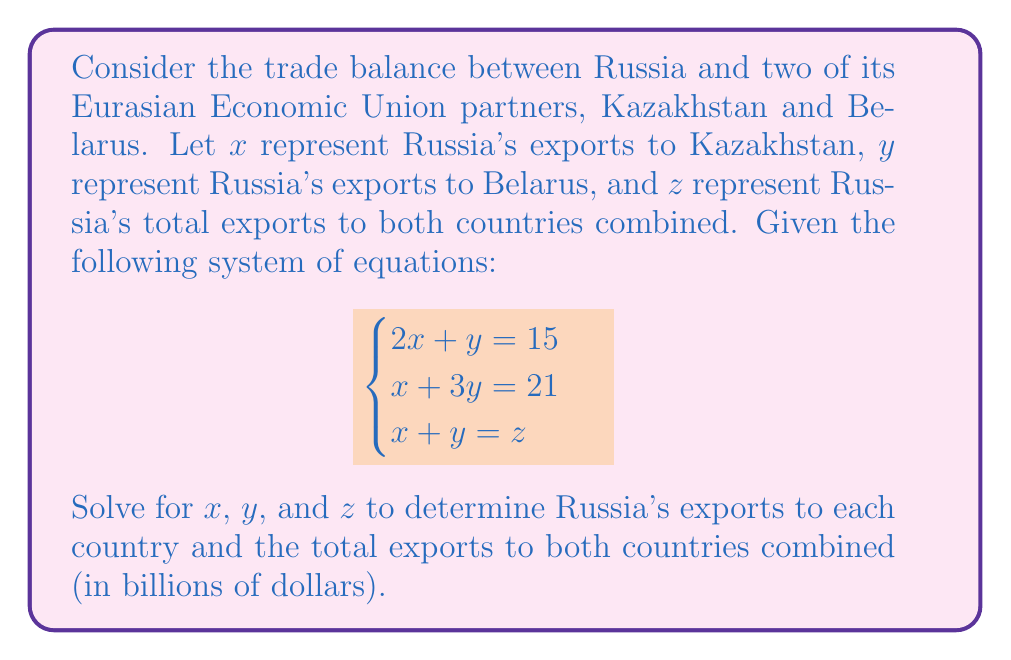Provide a solution to this math problem. Let's solve this system of equations step by step:

1) We have three equations:
   $$\begin{cases}
   2x + y = 15 \quad (1)\\
   x + 3y = 21 \quad (2)\\
   x + y = z \quad (3)
   \end{cases}$$

2) Let's start by solving for $x$ and $y$ using equations (1) and (2):
   Multiply equation (1) by 3 and equation (2) by 2:
   $$\begin{cases}
   6x + 3y = 45 \quad (4)\\
   2x + 6y = 42 \quad (5)
   \end{cases}$$

3) Subtract equation (5) from (4):
   $4x - 3y = 3$

4) Now we have:
   $$\begin{cases}
   2x + y = 15 \quad (1)\\
   4x - 3y = 3 \quad (6)
   \end{cases}$$

5) Multiply equation (1) by 2:
   $4x + 2y = 30 \quad (7)$

6) Subtract equation (6) from (7):
   $5y = 27$
   $y = \frac{27}{5} = 5.4$

7) Substitute this value of $y$ into equation (1):
   $2x + 5.4 = 15$
   $2x = 9.6$
   $x = 4.8$

8) Now that we have $x$ and $y$, we can find $z$ using equation (3):
   $z = x + y = 4.8 + 5.4 = 10.2$

Therefore, Russia's exports to Kazakhstan ($x$) are $4.8 billion, to Belarus ($y$) are $5.4 billion, and the total exports to both countries ($z$) are $10.2 billion.
Answer: $x = 4.8$, $y = 5.4$, $z = 10.2$ (in billions of dollars) 